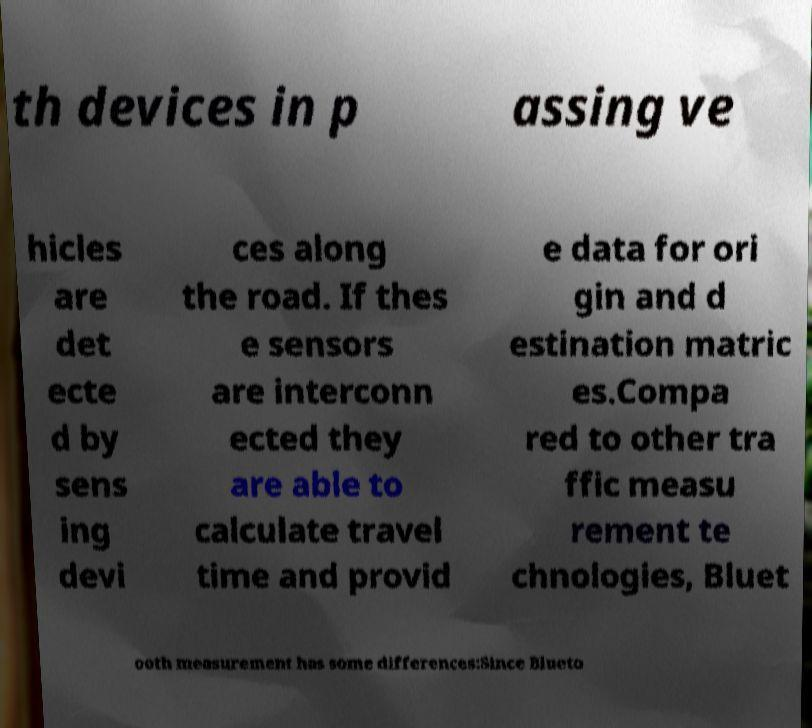Could you assist in decoding the text presented in this image and type it out clearly? th devices in p assing ve hicles are det ecte d by sens ing devi ces along the road. If thes e sensors are interconn ected they are able to calculate travel time and provid e data for ori gin and d estination matric es.Compa red to other tra ffic measu rement te chnologies, Bluet ooth measurement has some differences:Since Blueto 